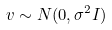Convert formula to latex. <formula><loc_0><loc_0><loc_500><loc_500>v \sim N ( 0 , \sigma ^ { 2 } I )</formula> 